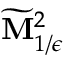Convert formula to latex. <formula><loc_0><loc_0><loc_500><loc_500>\widetilde { M } _ { 1 / \epsilon } ^ { 2 }</formula> 